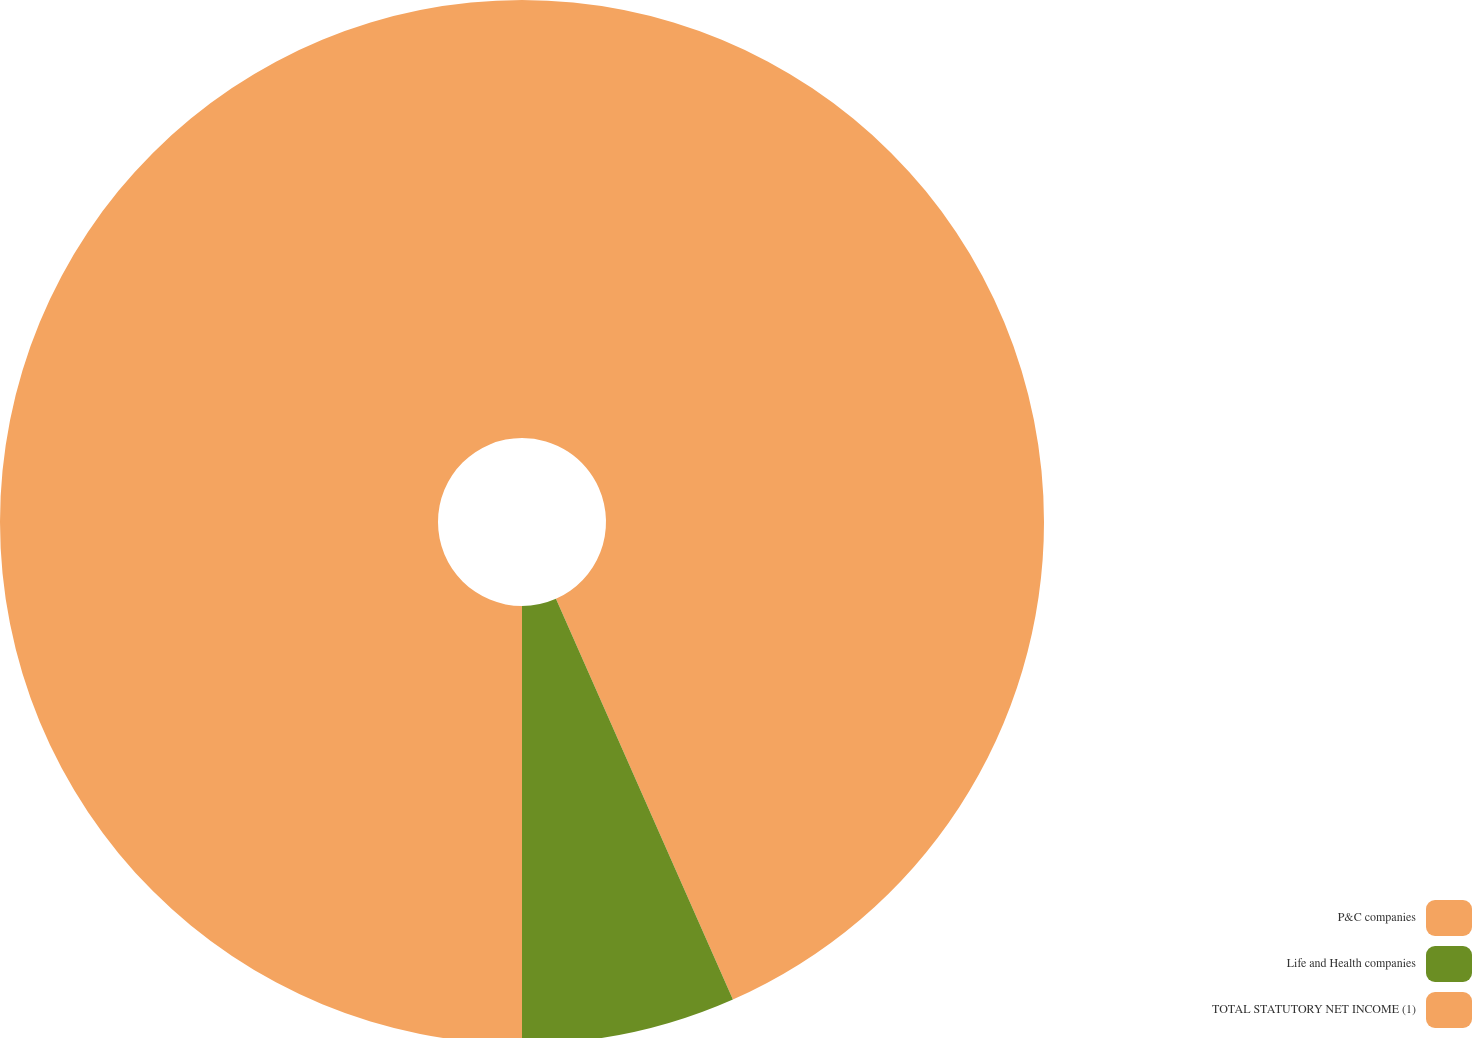Convert chart to OTSL. <chart><loc_0><loc_0><loc_500><loc_500><pie_chart><fcel>P&C companies<fcel>Life and Health companies<fcel>TOTAL STATUTORY NET INCOME (1)<nl><fcel>43.38%<fcel>6.62%<fcel>50.0%<nl></chart> 